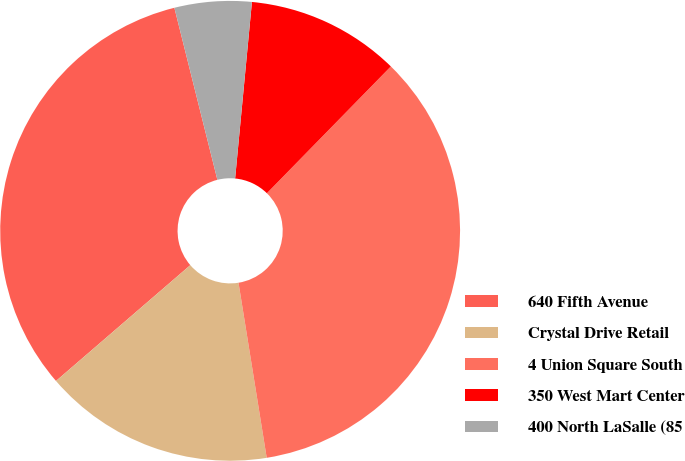Convert chart. <chart><loc_0><loc_0><loc_500><loc_500><pie_chart><fcel>640 Fifth Avenue<fcel>Crystal Drive Retail<fcel>4 Union Square South<fcel>350 West Mart Center<fcel>400 North LaSalle (85<nl><fcel>32.43%<fcel>16.22%<fcel>35.14%<fcel>10.81%<fcel>5.41%<nl></chart> 